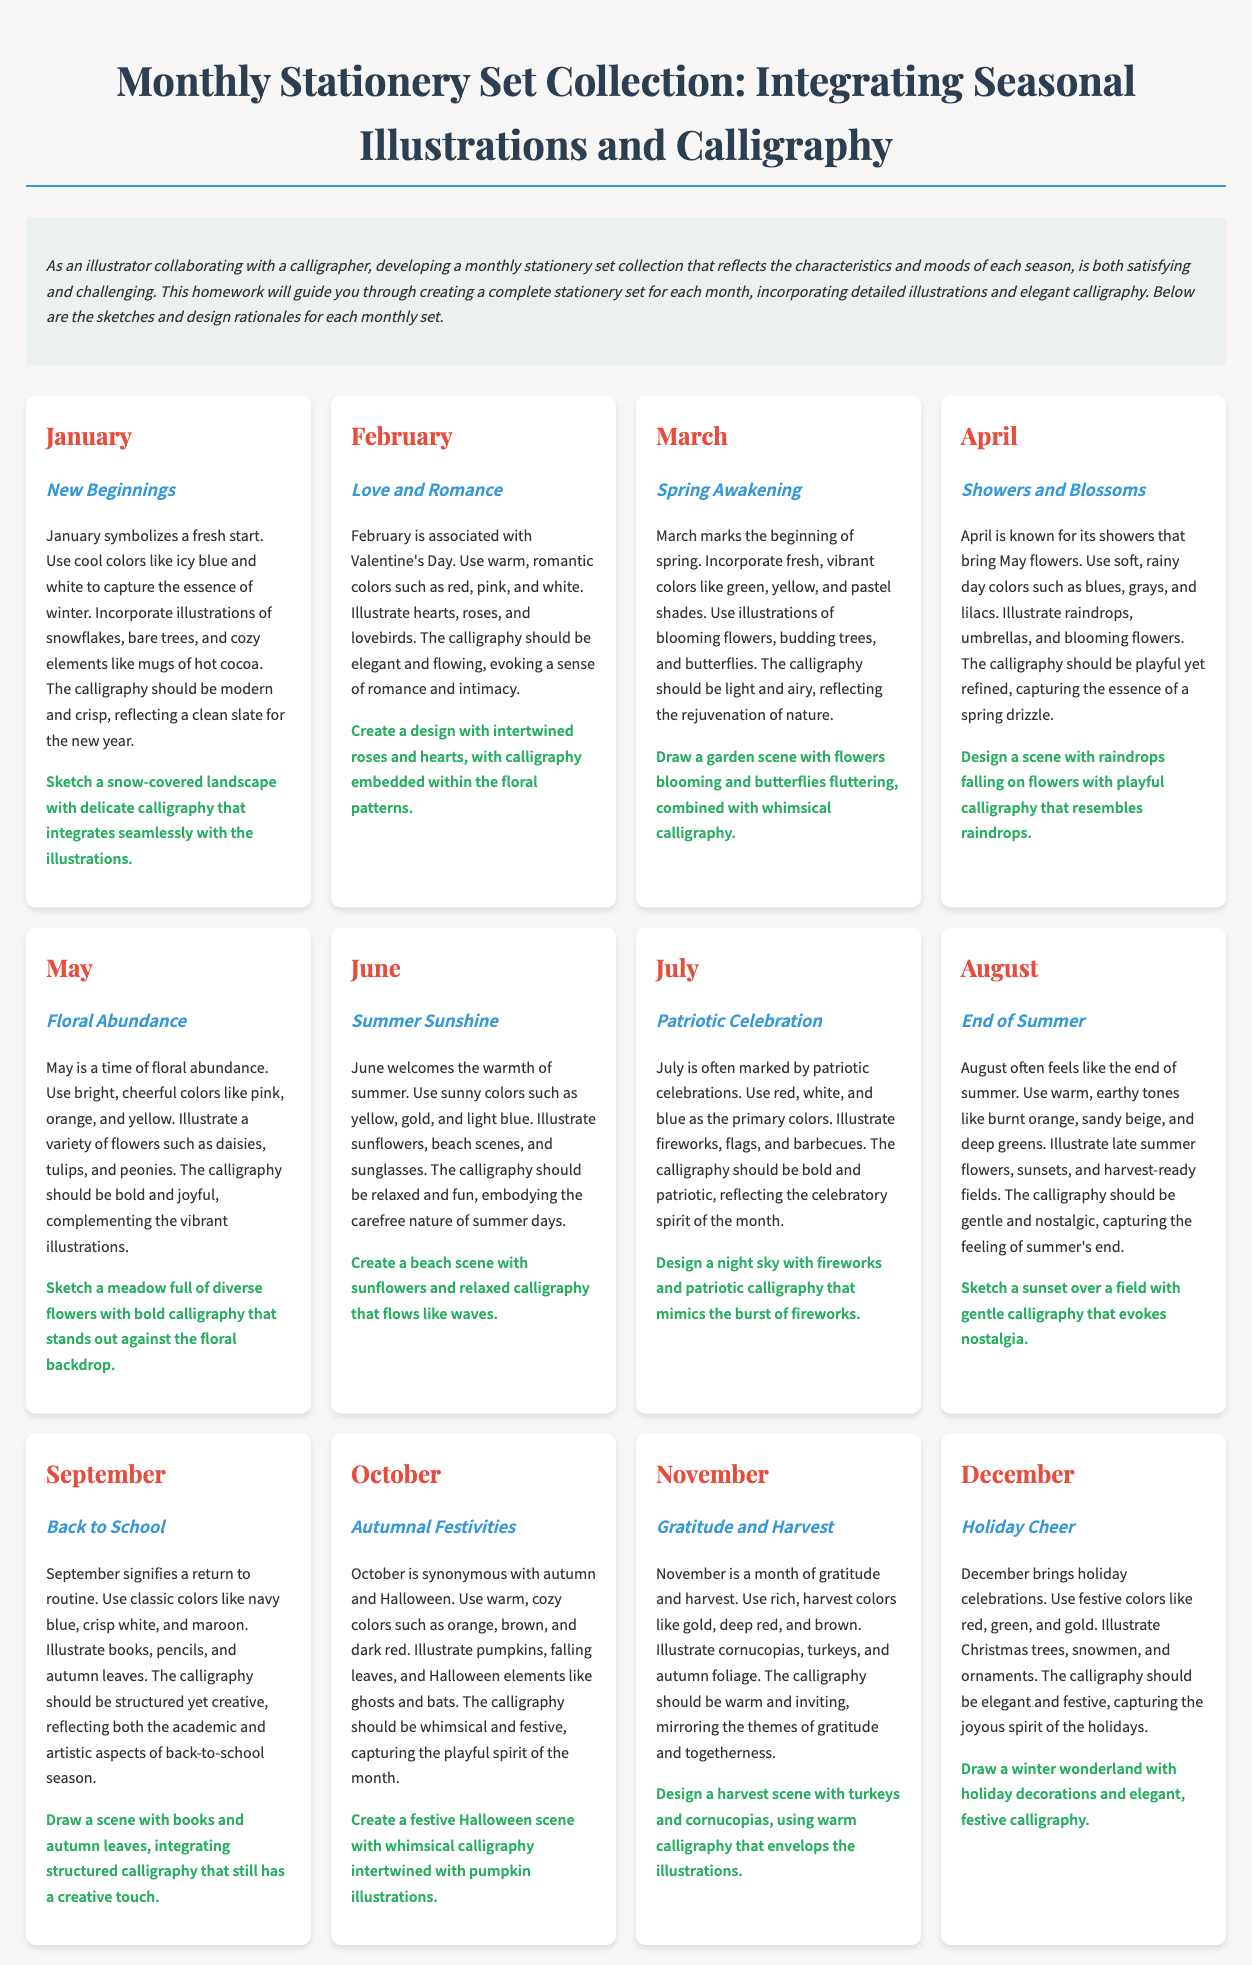What is the theme for January? The theme for January is "New Beginnings," representing a fresh start with winter elements.
Answer: New Beginnings Which month is associated with love and romance? February is associated with love and romance, especially due to Valentine's Day.
Answer: February What colors are used for the April stationery design? The colors for April's design are soft, rainy day colors such as blues, grays, and lilacs.
Answer: Blues, grays, and lilacs What type of illustrations are suggested for May? May suggests illustrations of a variety of flowers such as daisies, tulips, and peonies to showcase floral abundance.
Answer: Variety of flowers How does the calligraphy style change from July to August? The calligraphy style transitions from bold and patriotic in July to gentle and nostalgic in August.
Answer: Gentle and nostalgic Which month draws inspiration from autumn foliage and gratitude? November draws inspiration from autumn foliage and themes of gratitude and harvest.
Answer: November What is featured in the December stationery set? December features holiday decorations, including Christmas trees and snowmen, capturing the festive spirit.
Answer: Holiday decorations What kind of scene should be sketched for June? A beach scene with sunflowers and relaxed calligraphy that flows like waves should be sketched for June.
Answer: Beach scene What are the primary colors for the September design? The primary colors for September's design are classic colors like navy blue, crisp white, and maroon.
Answer: Navy blue, crisp white, and maroon 